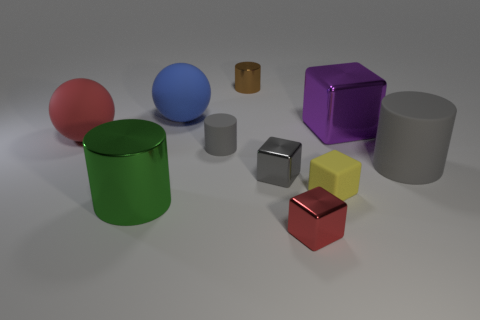Which objects in the picture look like they have a texture that's different from the others? The yellow cube has a matte surface, which contrasts with the other objects that display reflective, shiny surfaces. 